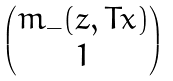<formula> <loc_0><loc_0><loc_500><loc_500>\begin{pmatrix} m _ { - } ( z , T x ) \\ 1 \end{pmatrix}</formula> 